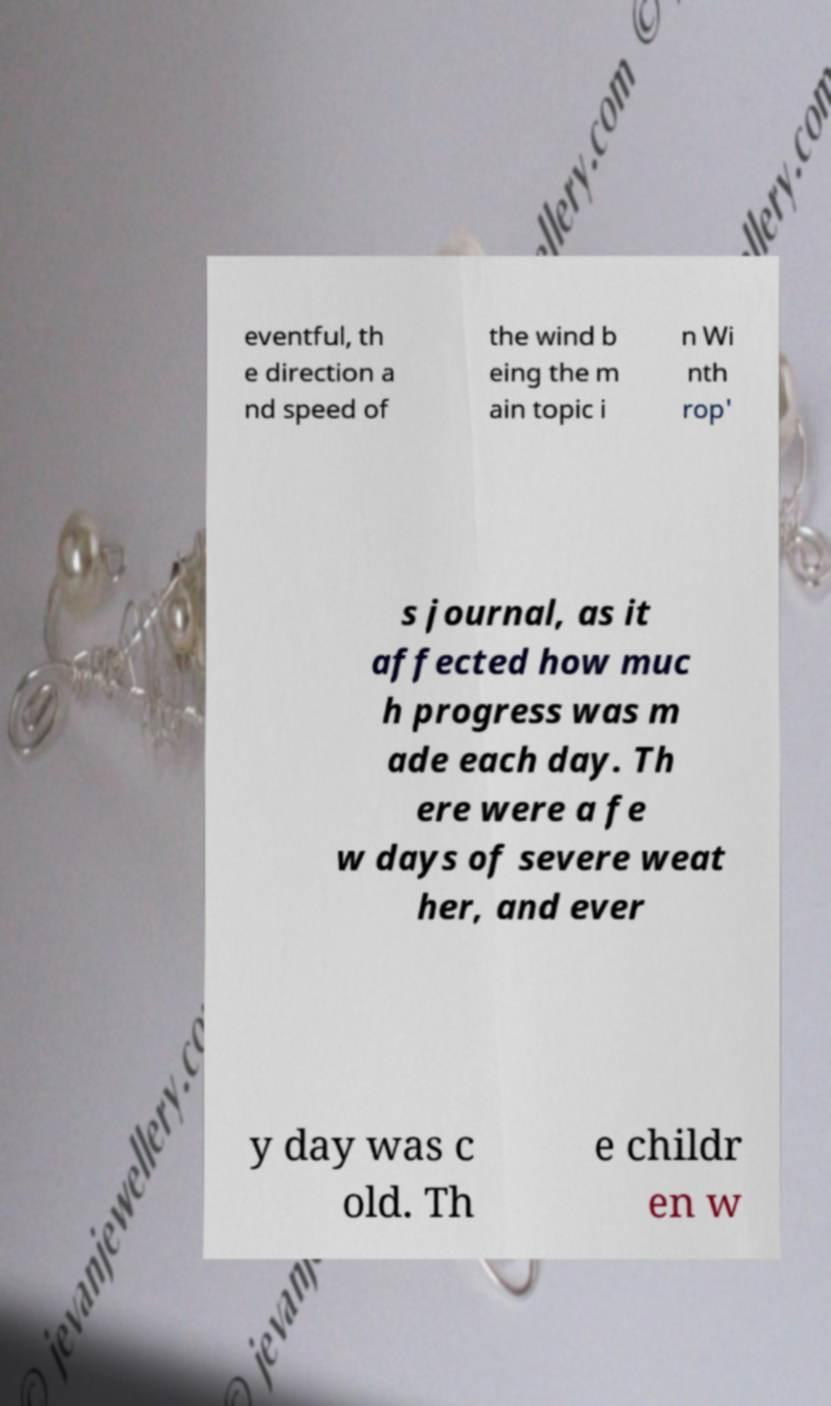For documentation purposes, I need the text within this image transcribed. Could you provide that? eventful, th e direction a nd speed of the wind b eing the m ain topic i n Wi nth rop' s journal, as it affected how muc h progress was m ade each day. Th ere were a fe w days of severe weat her, and ever y day was c old. Th e childr en w 